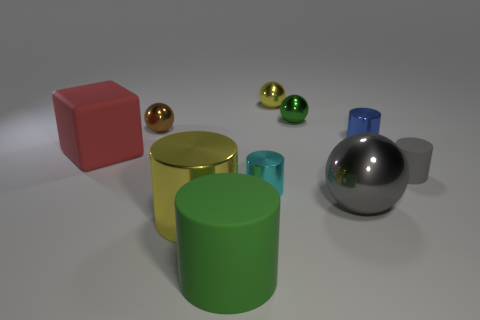The gray cylinder that is the same material as the large block is what size? The gray cylinder is small in size compared to the large red block next to it. This cylinder, made from a material that resembles matte metal similar to the large block, is approximately one-third the height of the red block, providing a stark size contrast in the image. 